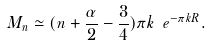Convert formula to latex. <formula><loc_0><loc_0><loc_500><loc_500>M _ { n } \simeq ( n + \frac { \alpha } { 2 } - \frac { 3 } { 4 } ) \pi k \ e ^ { - \pi k R } .</formula> 